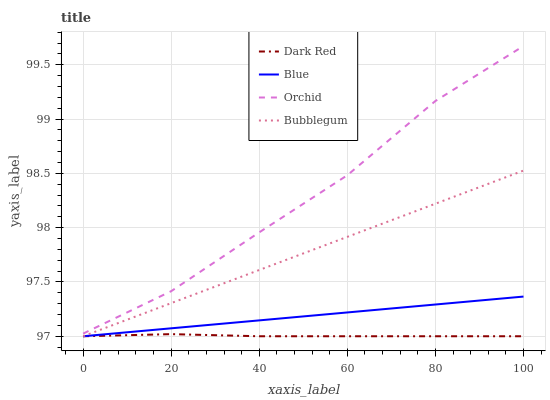Does Dark Red have the minimum area under the curve?
Answer yes or no. Yes. Does Orchid have the maximum area under the curve?
Answer yes or no. Yes. Does Bubblegum have the minimum area under the curve?
Answer yes or no. No. Does Bubblegum have the maximum area under the curve?
Answer yes or no. No. Is Blue the smoothest?
Answer yes or no. Yes. Is Orchid the roughest?
Answer yes or no. Yes. Is Dark Red the smoothest?
Answer yes or no. No. Is Dark Red the roughest?
Answer yes or no. No. Does Blue have the lowest value?
Answer yes or no. Yes. Does Orchid have the lowest value?
Answer yes or no. No. Does Orchid have the highest value?
Answer yes or no. Yes. Does Bubblegum have the highest value?
Answer yes or no. No. Is Blue less than Orchid?
Answer yes or no. Yes. Is Orchid greater than Dark Red?
Answer yes or no. Yes. Does Bubblegum intersect Blue?
Answer yes or no. Yes. Is Bubblegum less than Blue?
Answer yes or no. No. Is Bubblegum greater than Blue?
Answer yes or no. No. Does Blue intersect Orchid?
Answer yes or no. No. 